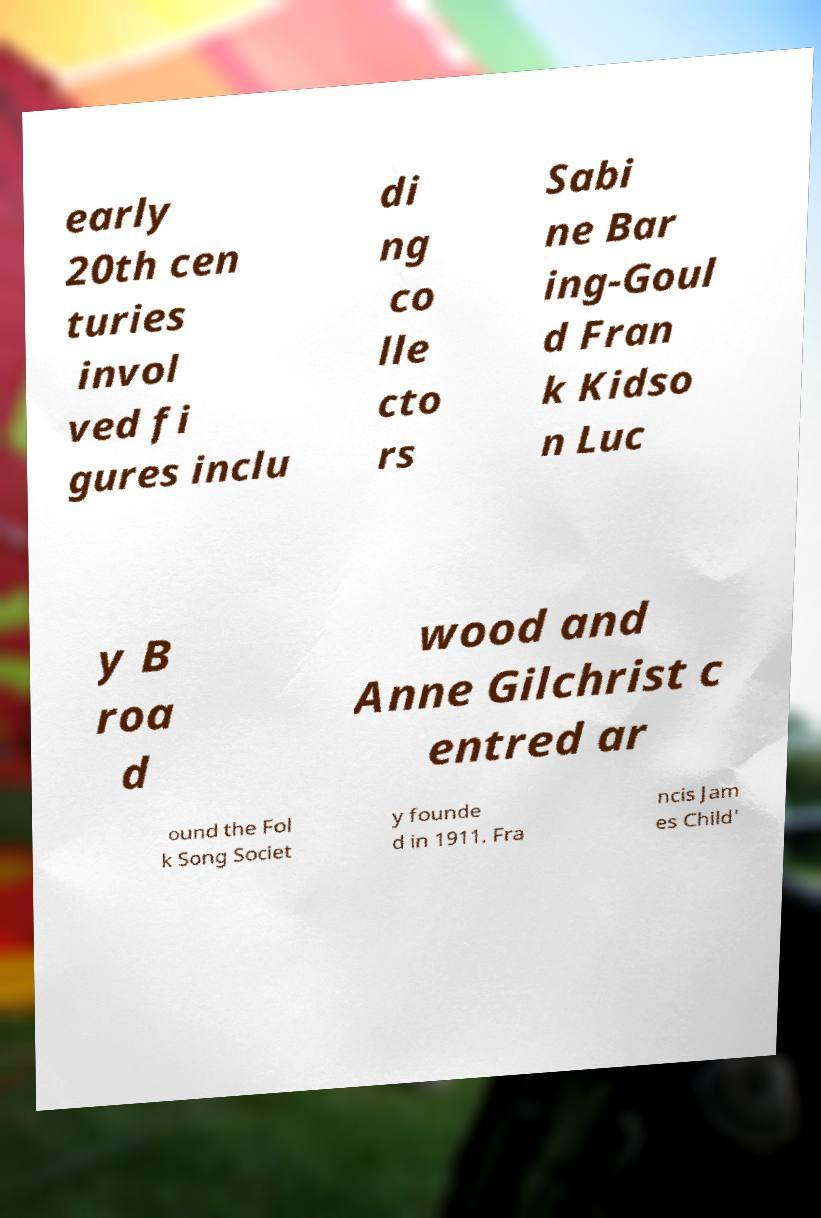Please read and relay the text visible in this image. What does it say? early 20th cen turies invol ved fi gures inclu di ng co lle cto rs Sabi ne Bar ing-Goul d Fran k Kidso n Luc y B roa d wood and Anne Gilchrist c entred ar ound the Fol k Song Societ y founde d in 1911. Fra ncis Jam es Child' 